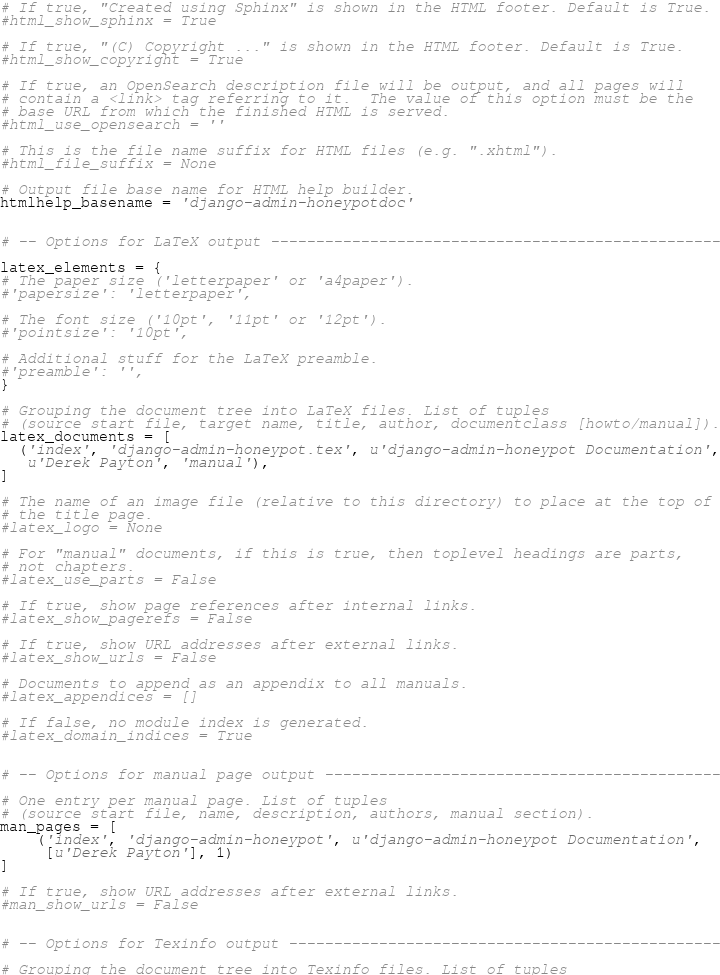<code> <loc_0><loc_0><loc_500><loc_500><_Python_>
# If true, "Created using Sphinx" is shown in the HTML footer. Default is True.
#html_show_sphinx = True

# If true, "(C) Copyright ..." is shown in the HTML footer. Default is True.
#html_show_copyright = True

# If true, an OpenSearch description file will be output, and all pages will
# contain a <link> tag referring to it.  The value of this option must be the
# base URL from which the finished HTML is served.
#html_use_opensearch = ''

# This is the file name suffix for HTML files (e.g. ".xhtml").
#html_file_suffix = None

# Output file base name for HTML help builder.
htmlhelp_basename = 'django-admin-honeypotdoc'


# -- Options for LaTeX output --------------------------------------------------

latex_elements = {
# The paper size ('letterpaper' or 'a4paper').
#'papersize': 'letterpaper',

# The font size ('10pt', '11pt' or '12pt').
#'pointsize': '10pt',

# Additional stuff for the LaTeX preamble.
#'preamble': '',
}

# Grouping the document tree into LaTeX files. List of tuples
# (source start file, target name, title, author, documentclass [howto/manual]).
latex_documents = [
  ('index', 'django-admin-honeypot.tex', u'django-admin-honeypot Documentation',
   u'Derek Payton', 'manual'),
]

# The name of an image file (relative to this directory) to place at the top of
# the title page.
#latex_logo = None

# For "manual" documents, if this is true, then toplevel headings are parts,
# not chapters.
#latex_use_parts = False

# If true, show page references after internal links.
#latex_show_pagerefs = False

# If true, show URL addresses after external links.
#latex_show_urls = False

# Documents to append as an appendix to all manuals.
#latex_appendices = []

# If false, no module index is generated.
#latex_domain_indices = True


# -- Options for manual page output --------------------------------------------

# One entry per manual page. List of tuples
# (source start file, name, description, authors, manual section).
man_pages = [
    ('index', 'django-admin-honeypot', u'django-admin-honeypot Documentation',
     [u'Derek Payton'], 1)
]

# If true, show URL addresses after external links.
#man_show_urls = False


# -- Options for Texinfo output ------------------------------------------------

# Grouping the document tree into Texinfo files. List of tuples</code> 